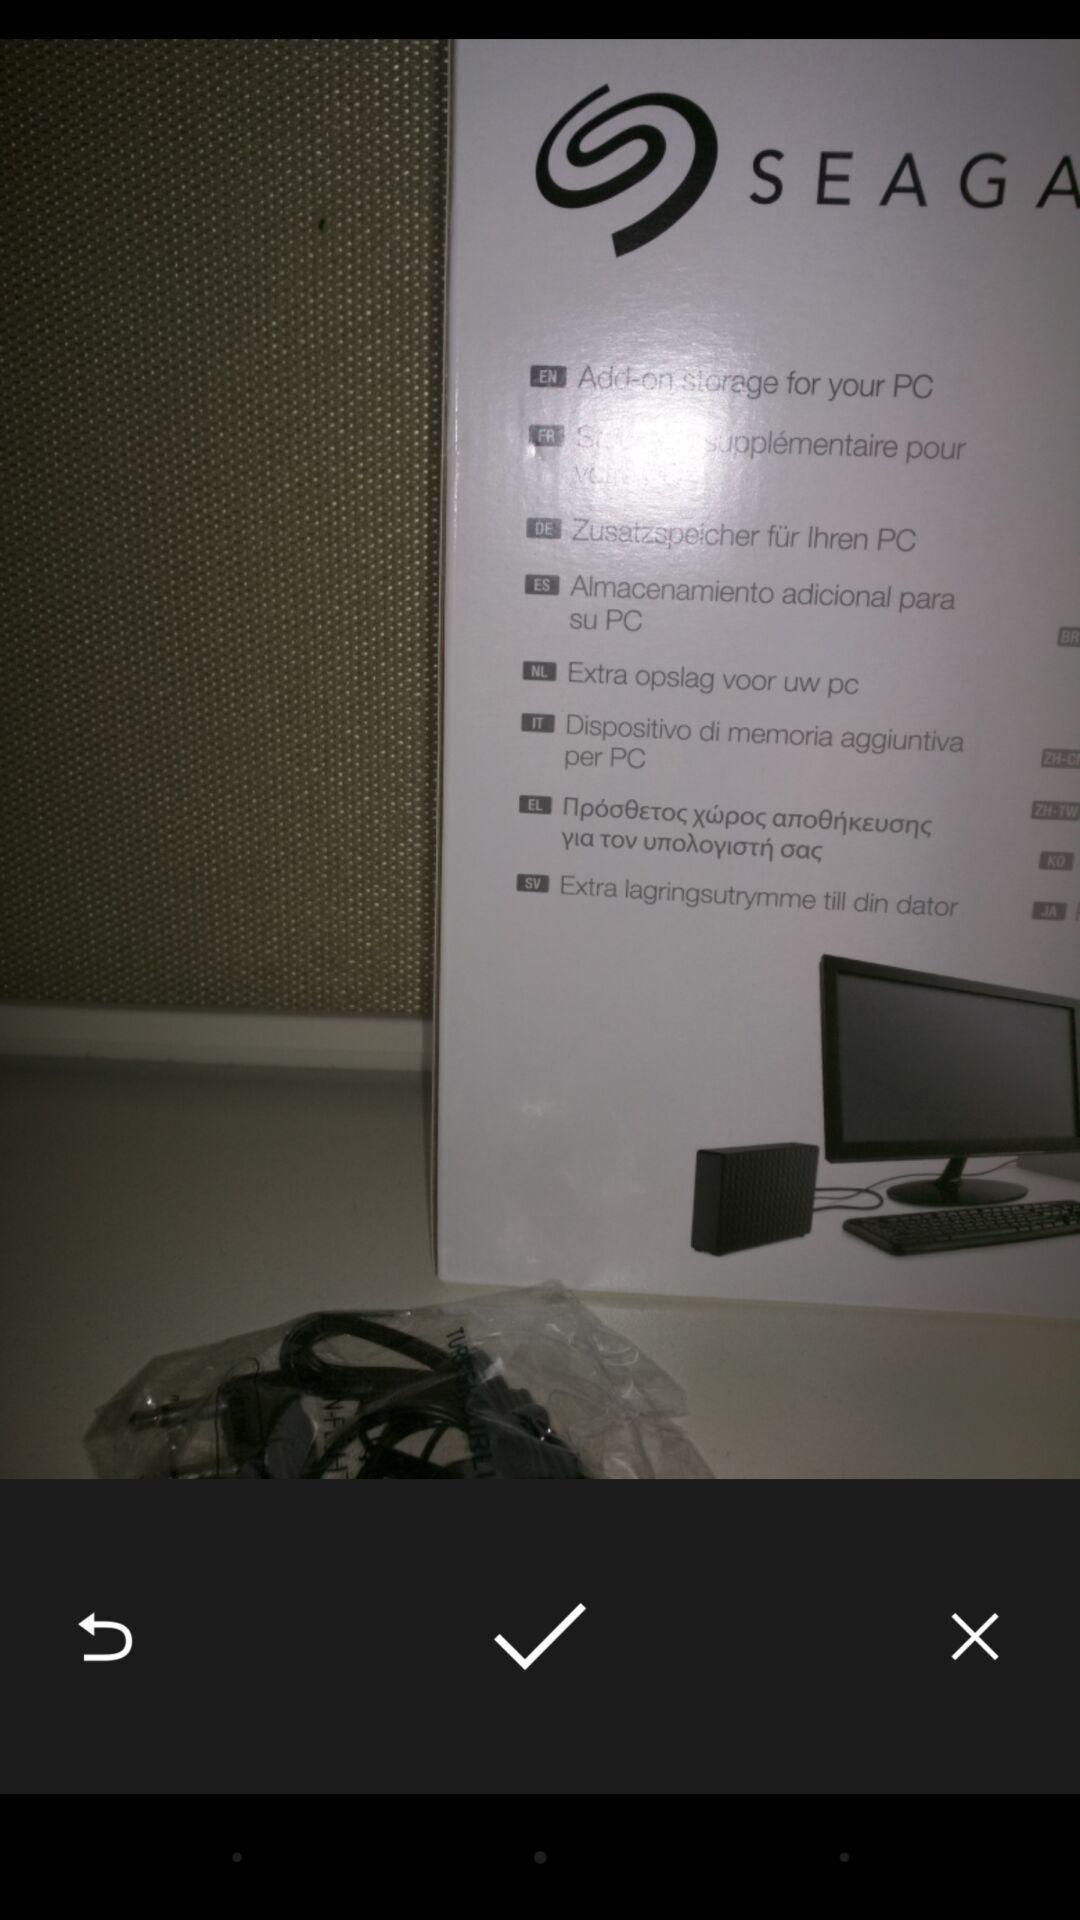Explain the elements present in this screenshot. Screen displaying an image with multiple controls. 